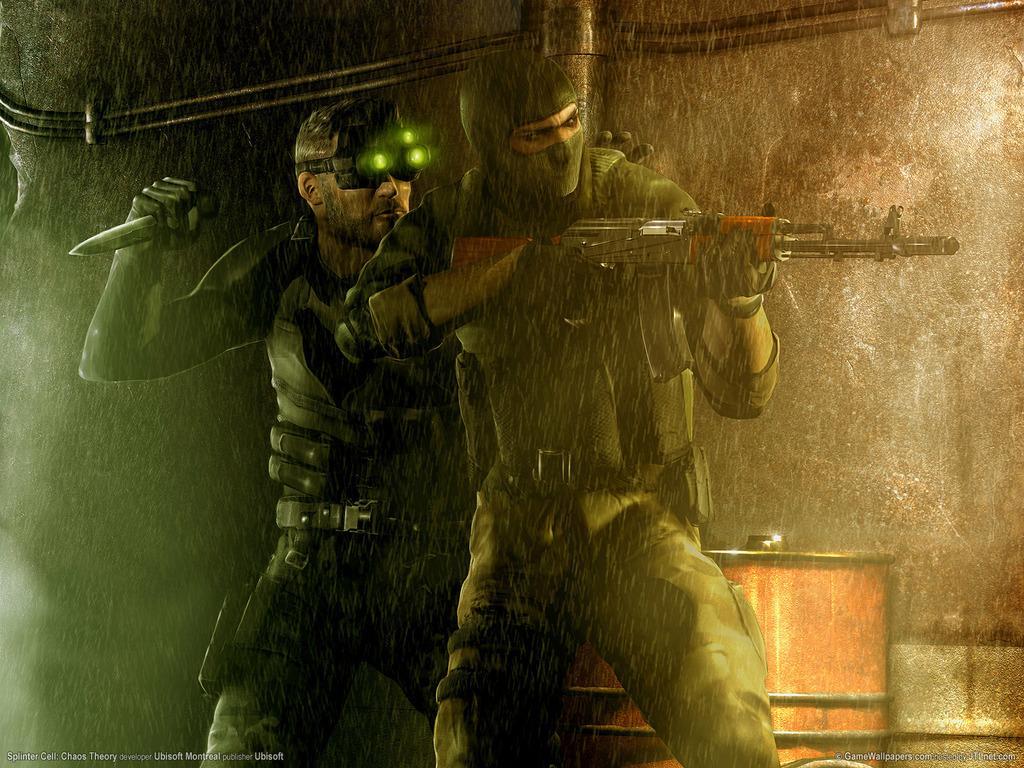In one or two sentences, can you explain what this image depicts? This is an animated image where I can see two persons standing here are holding weapons in their hands. The background of the image is dark where we can see few objects. 